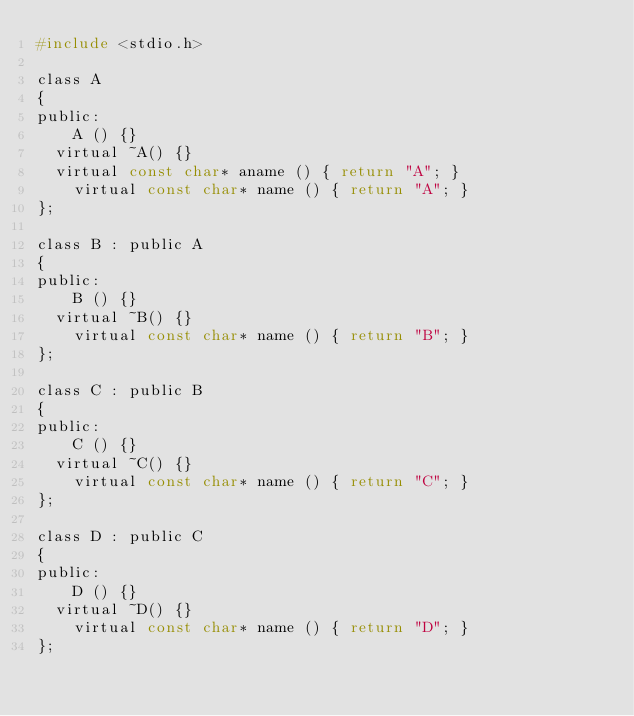<code> <loc_0><loc_0><loc_500><loc_500><_C_>#include <stdio.h>

class A
{
public:
	A () {}
  virtual ~A() {}
  virtual const char* aname () { return "A"; }
	virtual const char* name () { return "A"; } 
};

class B : public A
{
public:
	B () {}
  virtual ~B() {}
	virtual const char* name () { return "B"; } 
};

class C : public B
{
public:
	C () {}
  virtual ~C() {}
	virtual const char* name () { return "C"; } 
};

class D : public C
{
public:
	D () {}
  virtual ~D() {}
	virtual const char* name () { return "D"; } 
};

</code> 